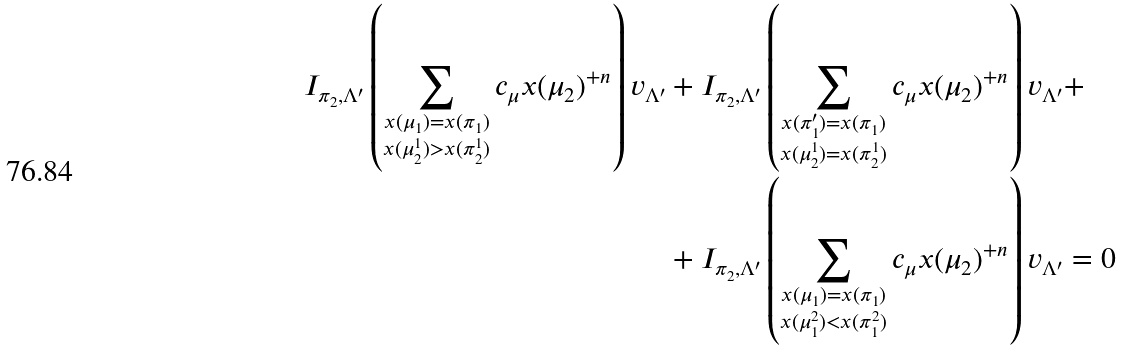Convert formula to latex. <formula><loc_0><loc_0><loc_500><loc_500>I _ { \pi _ { 2 } , \Lambda ^ { \prime } } \left ( \sum _ { \substack { x ( \mu _ { 1 } ) = x ( \pi _ { 1 } ) \\ x ( \mu _ { 2 } ^ { 1 } ) > x ( \pi _ { 2 } ^ { 1 } ) } } c _ { \mu } x ( \mu _ { 2 } ) ^ { + n } \right ) v _ { \Lambda ^ { \prime } } & + I _ { \pi _ { 2 } , \Lambda ^ { \prime } } \left ( \sum _ { \substack { x ( \pi _ { 1 } ^ { \prime } ) = x ( \pi _ { 1 } ) \\ x ( \mu _ { 2 } ^ { 1 } ) = x ( \pi _ { 2 } ^ { 1 } ) } } c _ { \mu } x ( \mu _ { 2 } ) ^ { + n } \right ) v _ { \Lambda ^ { \prime } } + \\ & + I _ { \pi _ { 2 } , \Lambda ^ { \prime } } \left ( \sum _ { \substack { x ( \mu _ { 1 } ) = x ( \pi _ { 1 } ) \\ x ( \mu _ { 1 } ^ { 2 } ) < x ( \pi _ { 1 } ^ { 2 } ) } } c _ { \mu } x ( \mu _ { 2 } ) ^ { + n } \right ) v _ { \Lambda ^ { \prime } } = 0</formula> 